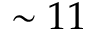<formula> <loc_0><loc_0><loc_500><loc_500>\sim 1 1</formula> 